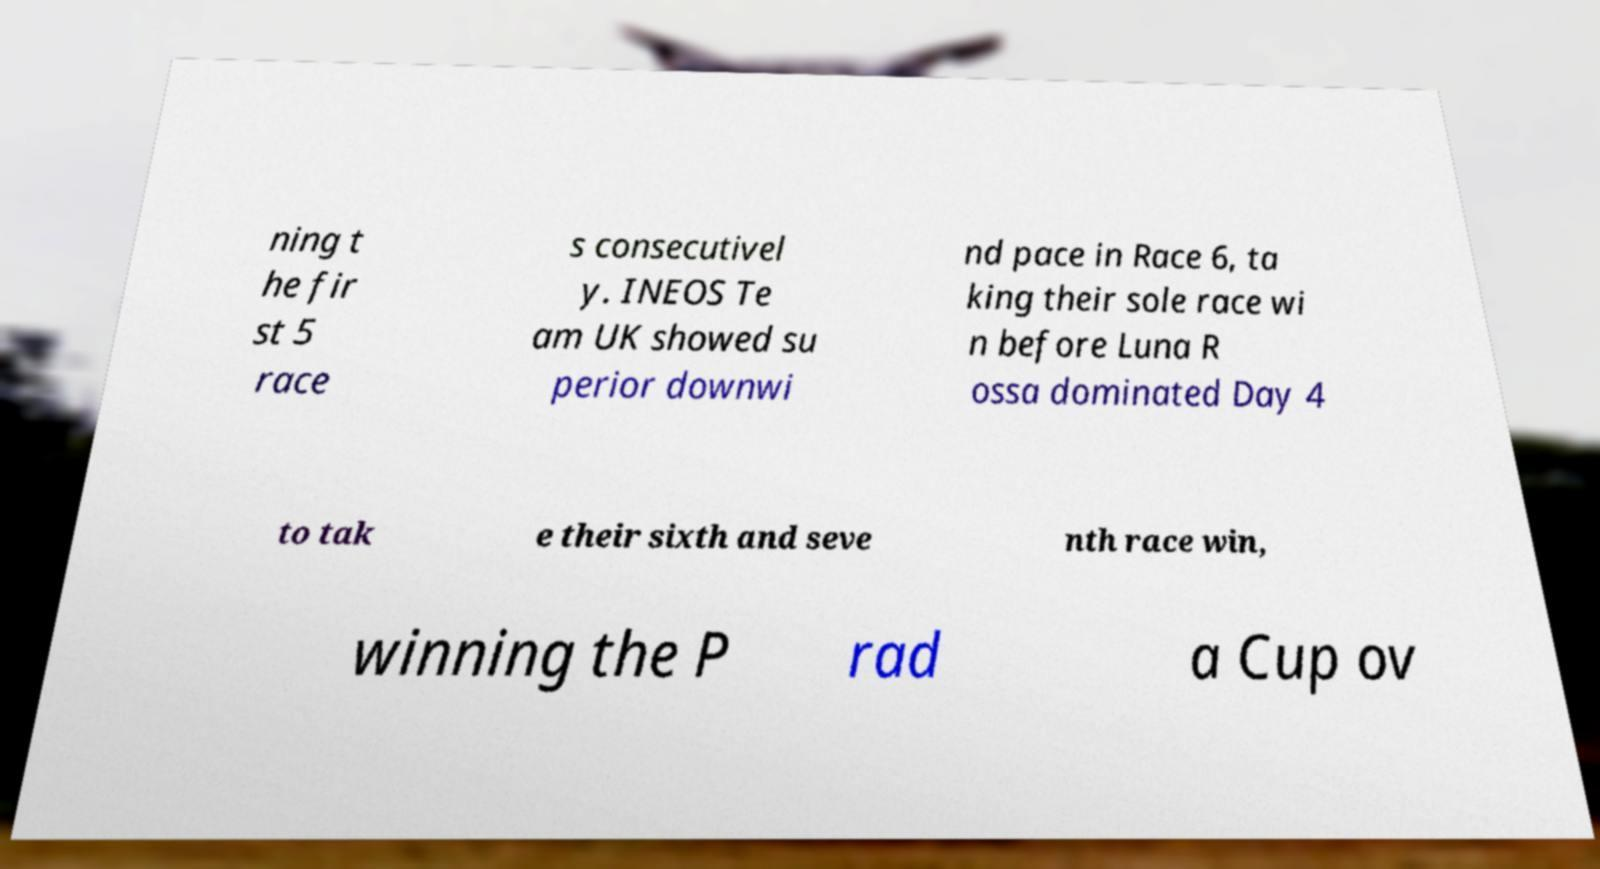For documentation purposes, I need the text within this image transcribed. Could you provide that? ning t he fir st 5 race s consecutivel y. INEOS Te am UK showed su perior downwi nd pace in Race 6, ta king their sole race wi n before Luna R ossa dominated Day 4 to tak e their sixth and seve nth race win, winning the P rad a Cup ov 